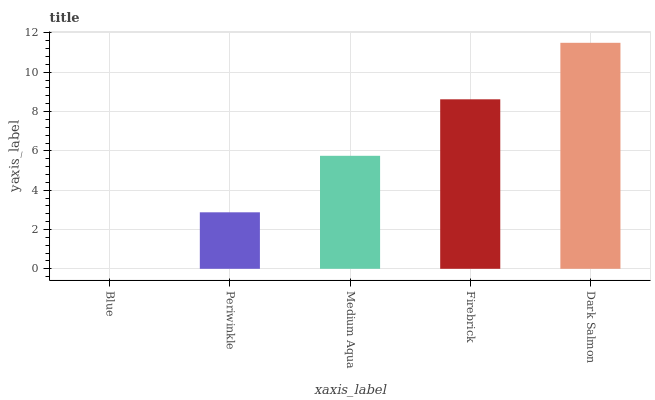Is Periwinkle the minimum?
Answer yes or no. No. Is Periwinkle the maximum?
Answer yes or no. No. Is Periwinkle greater than Blue?
Answer yes or no. Yes. Is Blue less than Periwinkle?
Answer yes or no. Yes. Is Blue greater than Periwinkle?
Answer yes or no. No. Is Periwinkle less than Blue?
Answer yes or no. No. Is Medium Aqua the high median?
Answer yes or no. Yes. Is Medium Aqua the low median?
Answer yes or no. Yes. Is Periwinkle the high median?
Answer yes or no. No. Is Periwinkle the low median?
Answer yes or no. No. 